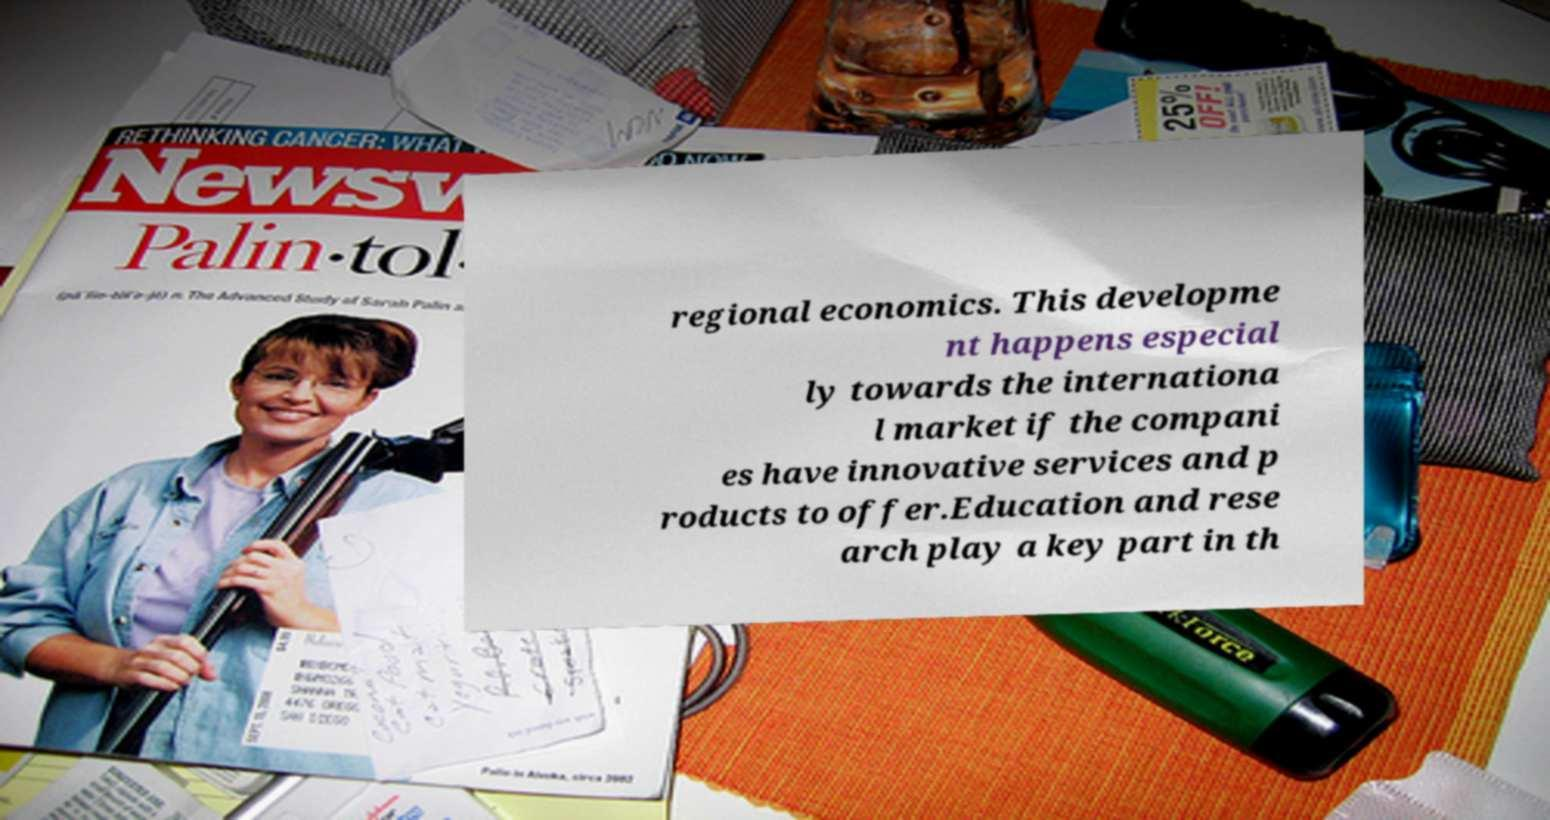There's text embedded in this image that I need extracted. Can you transcribe it verbatim? regional economics. This developme nt happens especial ly towards the internationa l market if the compani es have innovative services and p roducts to offer.Education and rese arch play a key part in th 